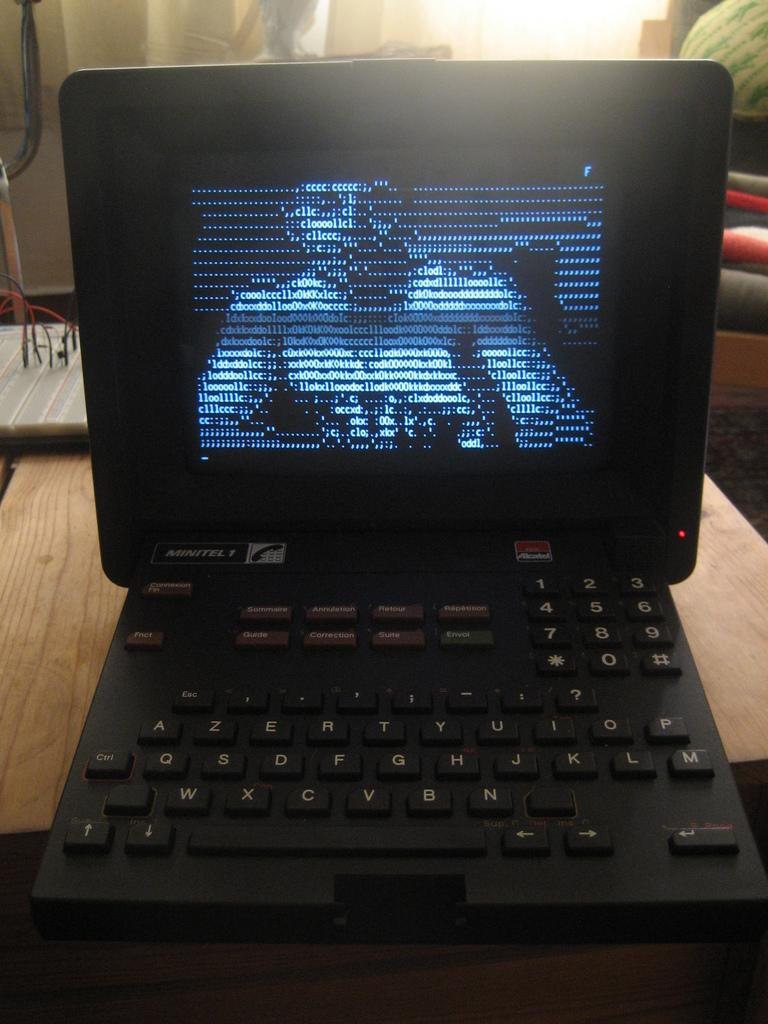What piece of furniture is present in the image? There is a table in the image. What electronic device is on the table? There is a laptop on the table. Can you describe what is behind the table in the image? There are other unspecified things behind the table. What type of hose is connected to the laptop in the image? There is no hose connected to the laptop in the image. What kind of stick can be seen being used to interact with the laptop in the image? There is no stick being used to interact with the laptop in the image. 